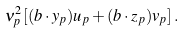<formula> <loc_0><loc_0><loc_500><loc_500>\nu _ { p } ^ { 2 } \left [ ( { b } \cdot { y } _ { p } ) u _ { p } + ( { b } \cdot { z } _ { p } ) v _ { p } \right ] .</formula> 